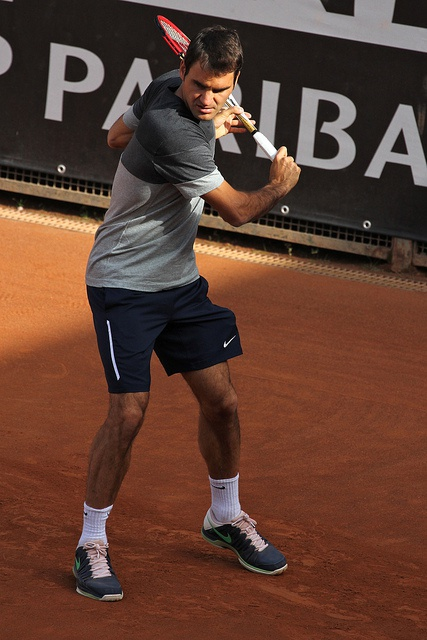Describe the objects in this image and their specific colors. I can see people in black, gray, maroon, and darkgray tones and tennis racket in black, white, darkgray, and red tones in this image. 